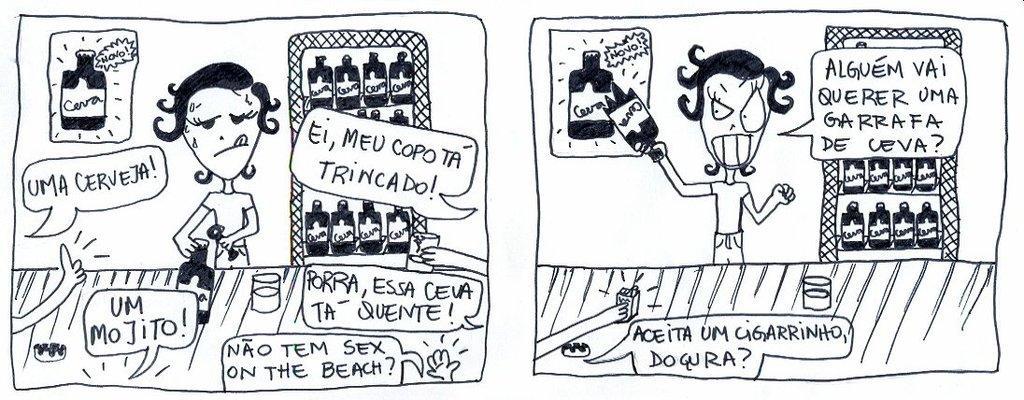Describe this image in one or two sentences. It is an animated picture,the image of two people are drawn and some quotations are written around the pictures of the people. 